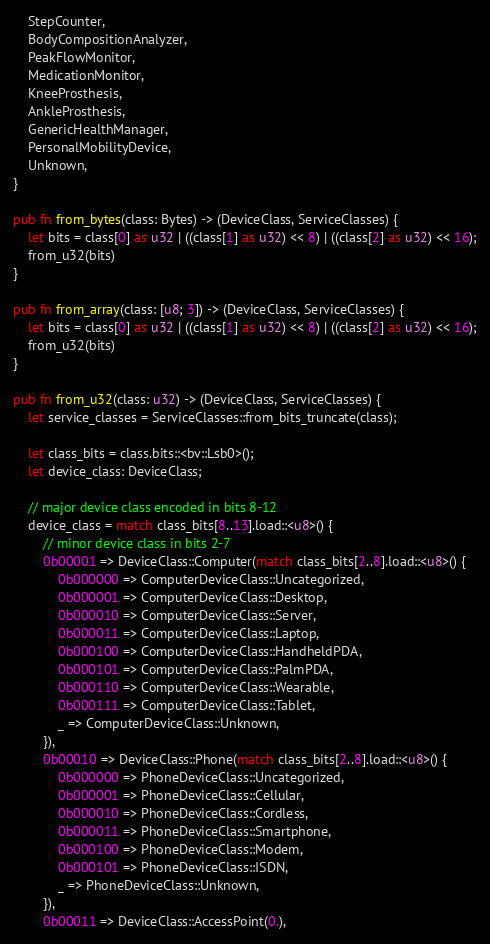Convert code to text. <code><loc_0><loc_0><loc_500><loc_500><_Rust_>    StepCounter,
    BodyCompositionAnalyzer,
    PeakFlowMonitor,
    MedicationMonitor,
    KneeProsthesis,
    AnkleProsthesis,
    GenericHealthManager,
    PersonalMobilityDevice,
    Unknown,
}

pub fn from_bytes(class: Bytes) -> (DeviceClass, ServiceClasses) {
    let bits = class[0] as u32 | ((class[1] as u32) << 8) | ((class[2] as u32) << 16);
    from_u32(bits)
}

pub fn from_array(class: [u8; 3]) -> (DeviceClass, ServiceClasses) {
    let bits = class[0] as u32 | ((class[1] as u32) << 8) | ((class[2] as u32) << 16);
    from_u32(bits)
}

pub fn from_u32(class: u32) -> (DeviceClass, ServiceClasses) {
    let service_classes = ServiceClasses::from_bits_truncate(class);

    let class_bits = class.bits::<bv::Lsb0>();
    let device_class: DeviceClass;

    // major device class encoded in bits 8-12
    device_class = match class_bits[8..13].load::<u8>() {
        // minor device class in bits 2-7
        0b00001 => DeviceClass::Computer(match class_bits[2..8].load::<u8>() {
            0b000000 => ComputerDeviceClass::Uncategorized,
            0b000001 => ComputerDeviceClass::Desktop,
            0b000010 => ComputerDeviceClass::Server,
            0b000011 => ComputerDeviceClass::Laptop,
            0b000100 => ComputerDeviceClass::HandheldPDA,
            0b000101 => ComputerDeviceClass::PalmPDA,
            0b000110 => ComputerDeviceClass::Wearable,
            0b000111 => ComputerDeviceClass::Tablet,
            _ => ComputerDeviceClass::Unknown,
        }),
        0b00010 => DeviceClass::Phone(match class_bits[2..8].load::<u8>() {
            0b000000 => PhoneDeviceClass::Uncategorized,
            0b000001 => PhoneDeviceClass::Cellular,
            0b000010 => PhoneDeviceClass::Cordless,
            0b000011 => PhoneDeviceClass::Smartphone,
            0b000100 => PhoneDeviceClass::Modem,
            0b000101 => PhoneDeviceClass::ISDN,
            _ => PhoneDeviceClass::Unknown,
        }),
        0b00011 => DeviceClass::AccessPoint(0.),</code> 